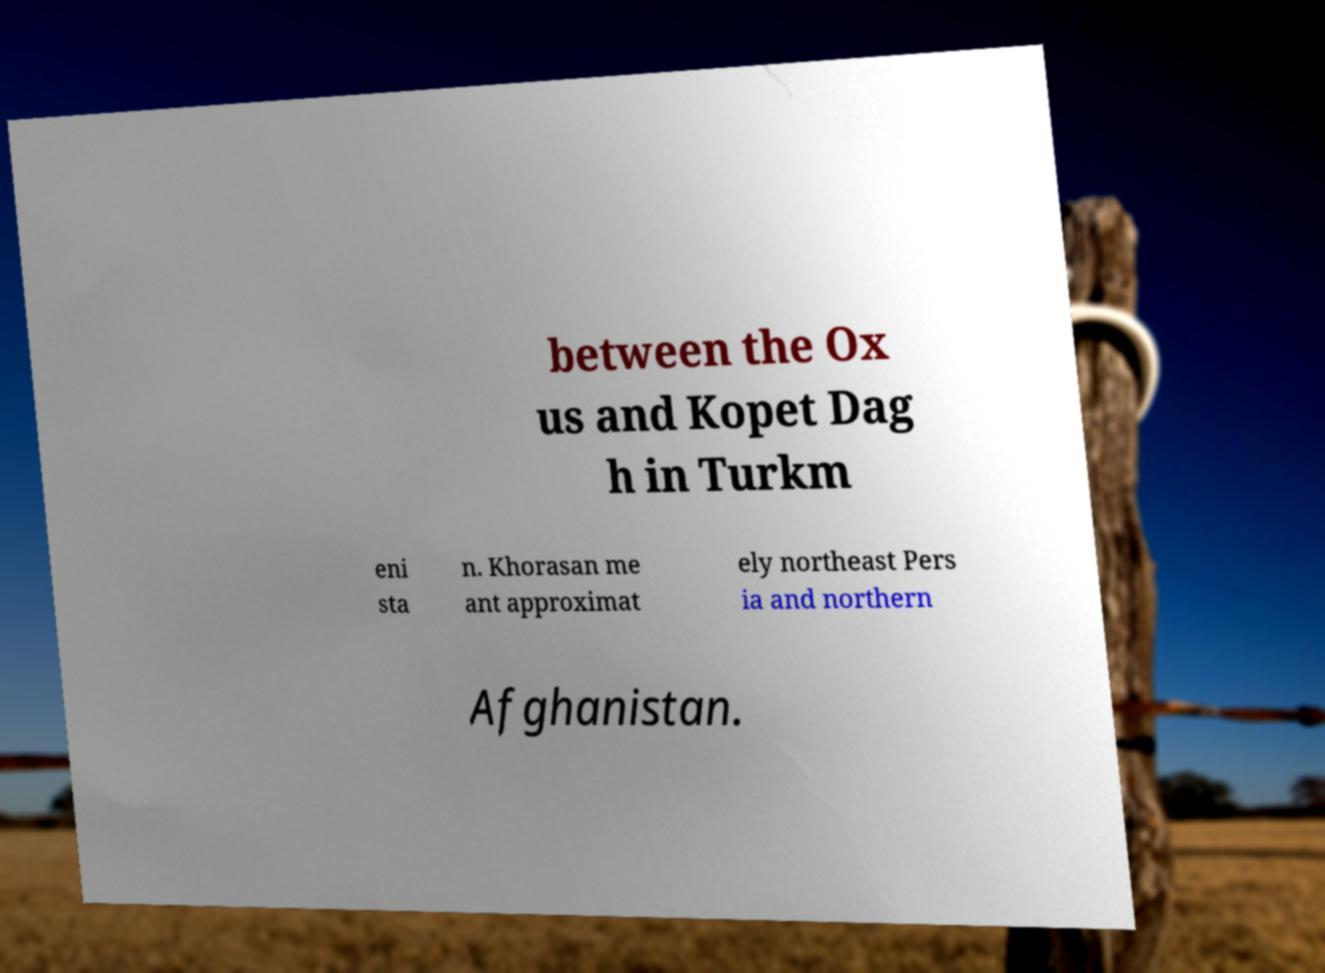What messages or text are displayed in this image? I need them in a readable, typed format. between the Ox us and Kopet Dag h in Turkm eni sta n. Khorasan me ant approximat ely northeast Pers ia and northern Afghanistan. 